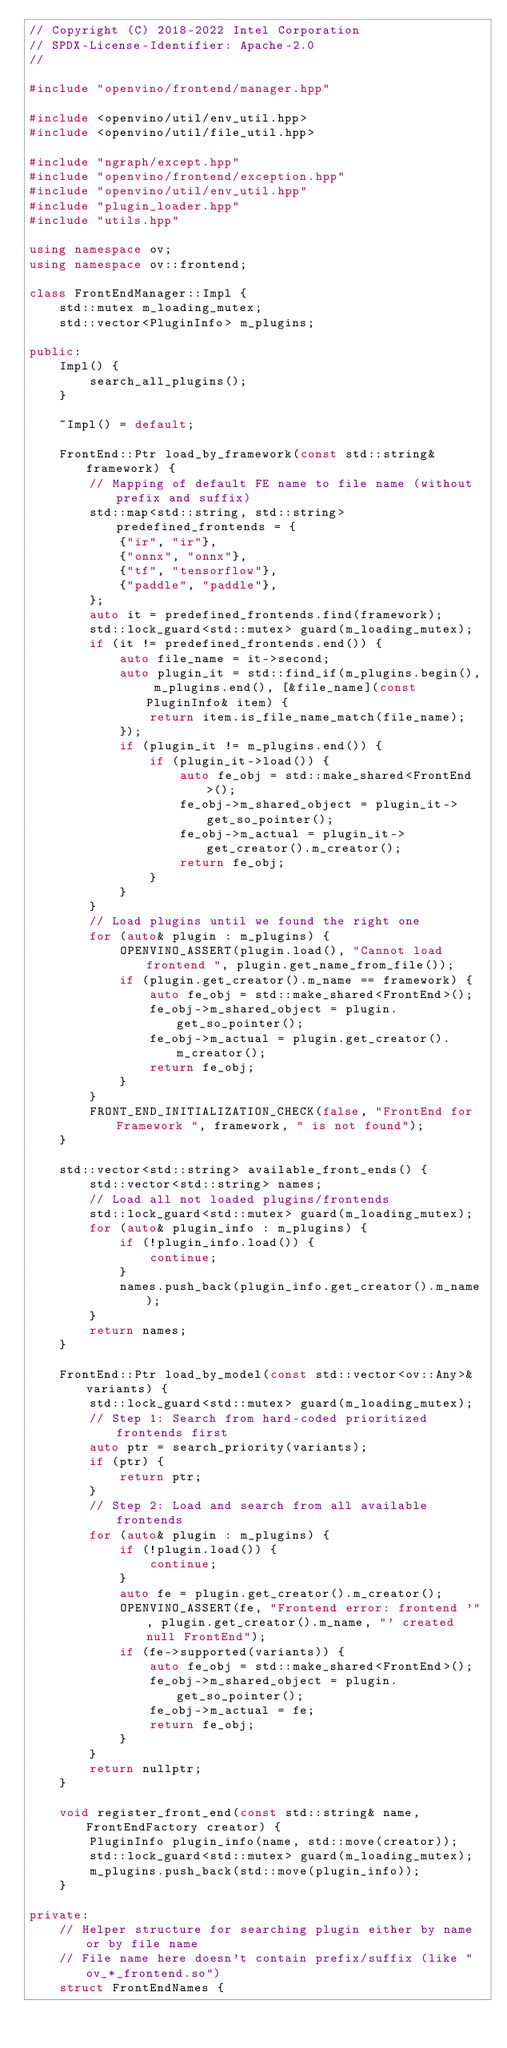<code> <loc_0><loc_0><loc_500><loc_500><_C++_>// Copyright (C) 2018-2022 Intel Corporation
// SPDX-License-Identifier: Apache-2.0
//

#include "openvino/frontend/manager.hpp"

#include <openvino/util/env_util.hpp>
#include <openvino/util/file_util.hpp>

#include "ngraph/except.hpp"
#include "openvino/frontend/exception.hpp"
#include "openvino/util/env_util.hpp"
#include "plugin_loader.hpp"
#include "utils.hpp"

using namespace ov;
using namespace ov::frontend;

class FrontEndManager::Impl {
    std::mutex m_loading_mutex;
    std::vector<PluginInfo> m_plugins;

public:
    Impl() {
        search_all_plugins();
    }

    ~Impl() = default;

    FrontEnd::Ptr load_by_framework(const std::string& framework) {
        // Mapping of default FE name to file name (without prefix and suffix)
        std::map<std::string, std::string> predefined_frontends = {
            {"ir", "ir"},
            {"onnx", "onnx"},
            {"tf", "tensorflow"},
            {"paddle", "paddle"},
        };
        auto it = predefined_frontends.find(framework);
        std::lock_guard<std::mutex> guard(m_loading_mutex);
        if (it != predefined_frontends.end()) {
            auto file_name = it->second;
            auto plugin_it = std::find_if(m_plugins.begin(), m_plugins.end(), [&file_name](const PluginInfo& item) {
                return item.is_file_name_match(file_name);
            });
            if (plugin_it != m_plugins.end()) {
                if (plugin_it->load()) {
                    auto fe_obj = std::make_shared<FrontEnd>();
                    fe_obj->m_shared_object = plugin_it->get_so_pointer();
                    fe_obj->m_actual = plugin_it->get_creator().m_creator();
                    return fe_obj;
                }
            }
        }
        // Load plugins until we found the right one
        for (auto& plugin : m_plugins) {
            OPENVINO_ASSERT(plugin.load(), "Cannot load frontend ", plugin.get_name_from_file());
            if (plugin.get_creator().m_name == framework) {
                auto fe_obj = std::make_shared<FrontEnd>();
                fe_obj->m_shared_object = plugin.get_so_pointer();
                fe_obj->m_actual = plugin.get_creator().m_creator();
                return fe_obj;
            }
        }
        FRONT_END_INITIALIZATION_CHECK(false, "FrontEnd for Framework ", framework, " is not found");
    }

    std::vector<std::string> available_front_ends() {
        std::vector<std::string> names;
        // Load all not loaded plugins/frontends
        std::lock_guard<std::mutex> guard(m_loading_mutex);
        for (auto& plugin_info : m_plugins) {
            if (!plugin_info.load()) {
                continue;
            }
            names.push_back(plugin_info.get_creator().m_name);
        }
        return names;
    }

    FrontEnd::Ptr load_by_model(const std::vector<ov::Any>& variants) {
        std::lock_guard<std::mutex> guard(m_loading_mutex);
        // Step 1: Search from hard-coded prioritized frontends first
        auto ptr = search_priority(variants);
        if (ptr) {
            return ptr;
        }
        // Step 2: Load and search from all available frontends
        for (auto& plugin : m_plugins) {
            if (!plugin.load()) {
                continue;
            }
            auto fe = plugin.get_creator().m_creator();
            OPENVINO_ASSERT(fe, "Frontend error: frontend '", plugin.get_creator().m_name, "' created null FrontEnd");
            if (fe->supported(variants)) {
                auto fe_obj = std::make_shared<FrontEnd>();
                fe_obj->m_shared_object = plugin.get_so_pointer();
                fe_obj->m_actual = fe;
                return fe_obj;
            }
        }
        return nullptr;
    }

    void register_front_end(const std::string& name, FrontEndFactory creator) {
        PluginInfo plugin_info(name, std::move(creator));
        std::lock_guard<std::mutex> guard(m_loading_mutex);
        m_plugins.push_back(std::move(plugin_info));
    }

private:
    // Helper structure for searching plugin either by name or by file name
    // File name here doesn't contain prefix/suffix (like "ov_*_frontend.so")
    struct FrontEndNames {</code> 